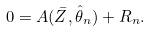<formula> <loc_0><loc_0><loc_500><loc_500>0 = A ( \bar { Z } , \hat { \theta } _ { n } ) + R _ { n } .</formula> 